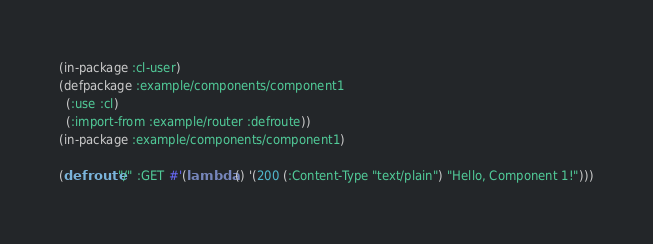Convert code to text. <code><loc_0><loc_0><loc_500><loc_500><_Lisp_>(in-package :cl-user)
(defpackage :example/components/component1
  (:use :cl)
  (:import-from :example/router :defroute))
(in-package :example/components/component1)

(defroute "/" :GET #'(lambda () '(200 (:Content-Type "text/plain") "Hello, Component 1!")))
</code> 